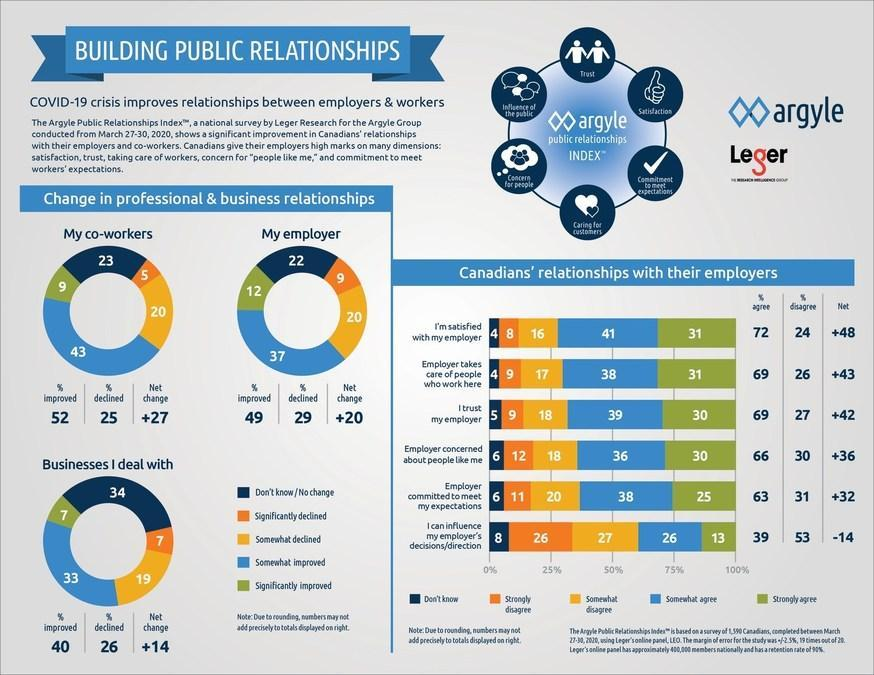What percent of the Canadians strongly disagree that they can influence their employer's decision as per the survey conducted from March 27-30, 2020?
Answer the question with a short phrase. 26 What percent of Canadians show a significant decline in their relationship with their employer as per the survey conducted from March 27-30, 2020? 9 What percent of the Canadians disagree that their employer takes care of people who work there as per the survey conducted from March 27-30, 2020? 26 What percent of Canadians show a significant improvement in the business which they dealt with as per the survey conducted from March 27-30, 2020? 7 What percent of the Canadians strongly agree that they trust their employer as per the survey conducted from March 27-30, 2020? 30 What percent of Canadians significantly improved their relationship with their employer as per the survey conducted from March 27-30, 2020? 12 What percent of Canadians show a significant decline in their relationship with their co-workers as per the survey conducted from March 27-30, 2020? 5 What percent of Canadians significantly improved their relationship with their co-workers as per the survey conducted from March 27-30, 2020? 9 What percent of the Canadians don't know whether they can influence their employer's decision as per the survey conducted from March 27-30, 2020? 8 What percent of the Canadians don't know whether their employer will take care of the people who work there as per the survey conducted from March 27-30, 2020? 4 